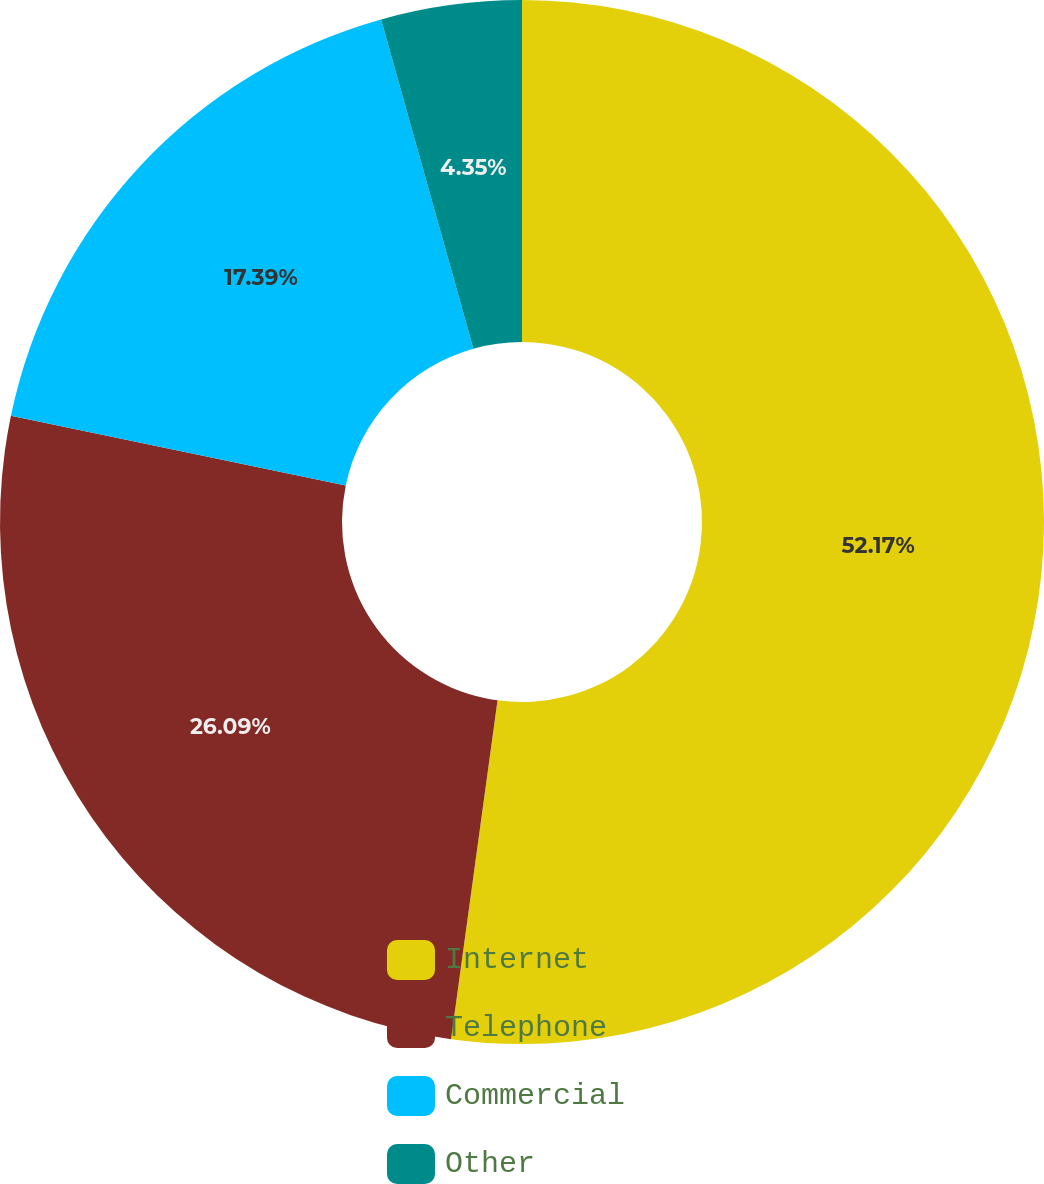<chart> <loc_0><loc_0><loc_500><loc_500><pie_chart><fcel>Internet<fcel>Telephone<fcel>Commercial<fcel>Other<nl><fcel>52.17%<fcel>26.09%<fcel>17.39%<fcel>4.35%<nl></chart> 